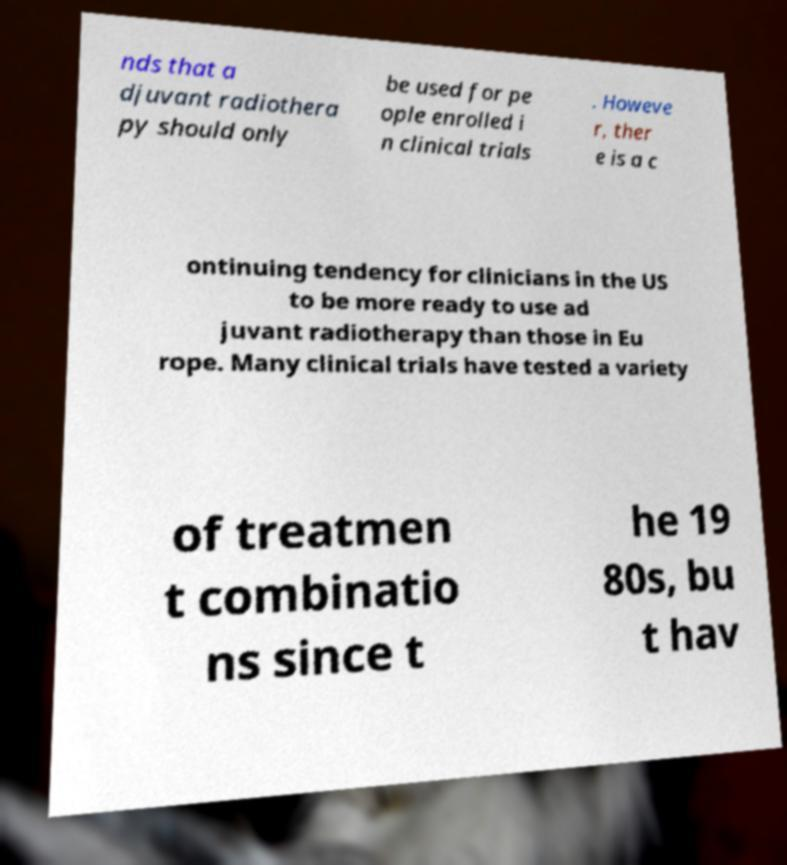Could you assist in decoding the text presented in this image and type it out clearly? nds that a djuvant radiothera py should only be used for pe ople enrolled i n clinical trials . Howeve r, ther e is a c ontinuing tendency for clinicians in the US to be more ready to use ad juvant radiotherapy than those in Eu rope. Many clinical trials have tested a variety of treatmen t combinatio ns since t he 19 80s, bu t hav 